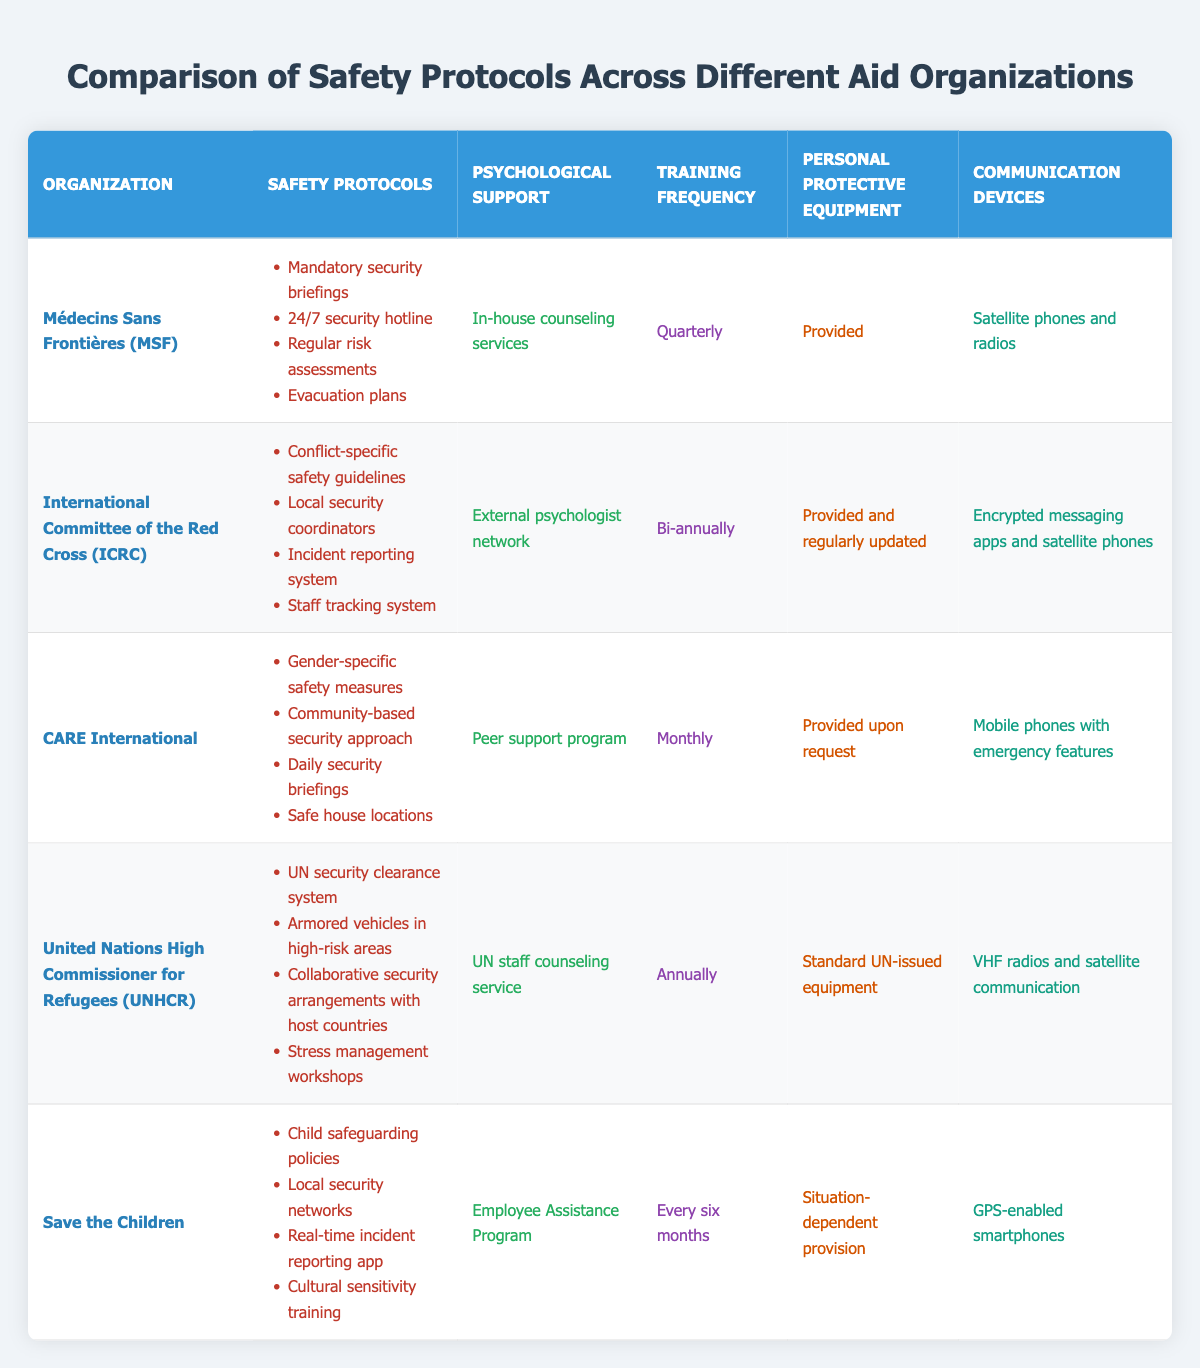What safety protocols does CARE International have? CARE International has the following safety protocols: Gender-specific safety measures, Community-based security approach, Daily security briefings, Safe house locations. These can be found directly in the table under the CARE International row.
Answer: Gender-specific safety measures, Community-based security approach, Daily security briefings, Safe house locations Which organization provides in-house counseling services? The table lists Médecins Sans Frontières (MSF) as providing in-house counseling services under the psychological support column. This specific information is present in the respective row and column for MSF.
Answer: Médecins Sans Frontières (MSF) How often does Save the Children provide training? The training frequency for Save the Children is found in the respective row in the training frequency column. It is mentioned as "Every six months." Therefore, the answer comes straight from that source.
Answer: Every six months Is the personal protective equipment provided by International Committee of the Red Cross regularly updated? Looking at the table, the International Committee of the Red Cross specifies that personal protective equipment is "Provided and regularly updated." This confirms that it is updated and is visible in the corresponding row.
Answer: Yes What is the difference in training frequency between Médecins Sans Frontières and United Nations High Commissioner for Refugees? The training frequency for Médecins Sans Frontières is "Quarterly," and for United Nations High Commissioner for Refugees, it is "Annually." To find the difference, we can convert quarterly to an equivalent annual frequency (4 times a year) and compare it to the annual frequency (1 time a year). Thus, the difference is found via the logic of frequency, which indicates that MSF trains 3 times more often than UNHCR.
Answer: MSF trains 3 times more often How many organizations have personal protective equipment provided upon request? The table shows that out of the five organizations, only CARE International specifies that personal protective equipment is "Provided upon request." By counting all rows, we find that only one organization fits this criteria.
Answer: One organization Does Save the Children have a local security network as part of their safety protocols? According to the table, Save the Children includes "Local security networks" in their safety protocols, indicated in the corresponding row under safety protocols. This confirms the existence of local security networks in their procedures.
Answer: Yes Which organization has the most frequent training sessions, and what is the frequency? By examining the training frequency column, CARE International has "Monthly," which is the most frequent compared to others. So, the answer directly relates to the training frequency by comparing all entries in that column.
Answer: CARE International, Monthly What type of communication devices does Médecins Sans Frontières use? The table indicates that Médecins Sans Frontières uses "Satellite phones and radios" as communication devices, which is visible in the communication devices column for that organization.
Answer: Satellite phones and radios What psychological support does United Nations High Commissioner for Refugees provide? The psychological support indicated for the United Nations High Commissioner for Refugees in the table is "UN staff counseling service." This information is clearly listed for UNHCR under the psychological support column.
Answer: UN staff counseling service 